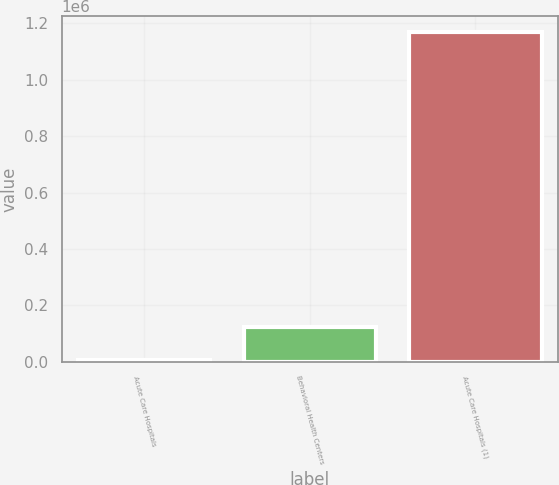Convert chart. <chart><loc_0><loc_0><loc_500><loc_500><bar_chart><fcel>Acute Care Hospitals<fcel>Behavioral Health Centers<fcel>Acute Care Hospitals (1)<nl><fcel>5776<fcel>121971<fcel>1.16773e+06<nl></chart> 